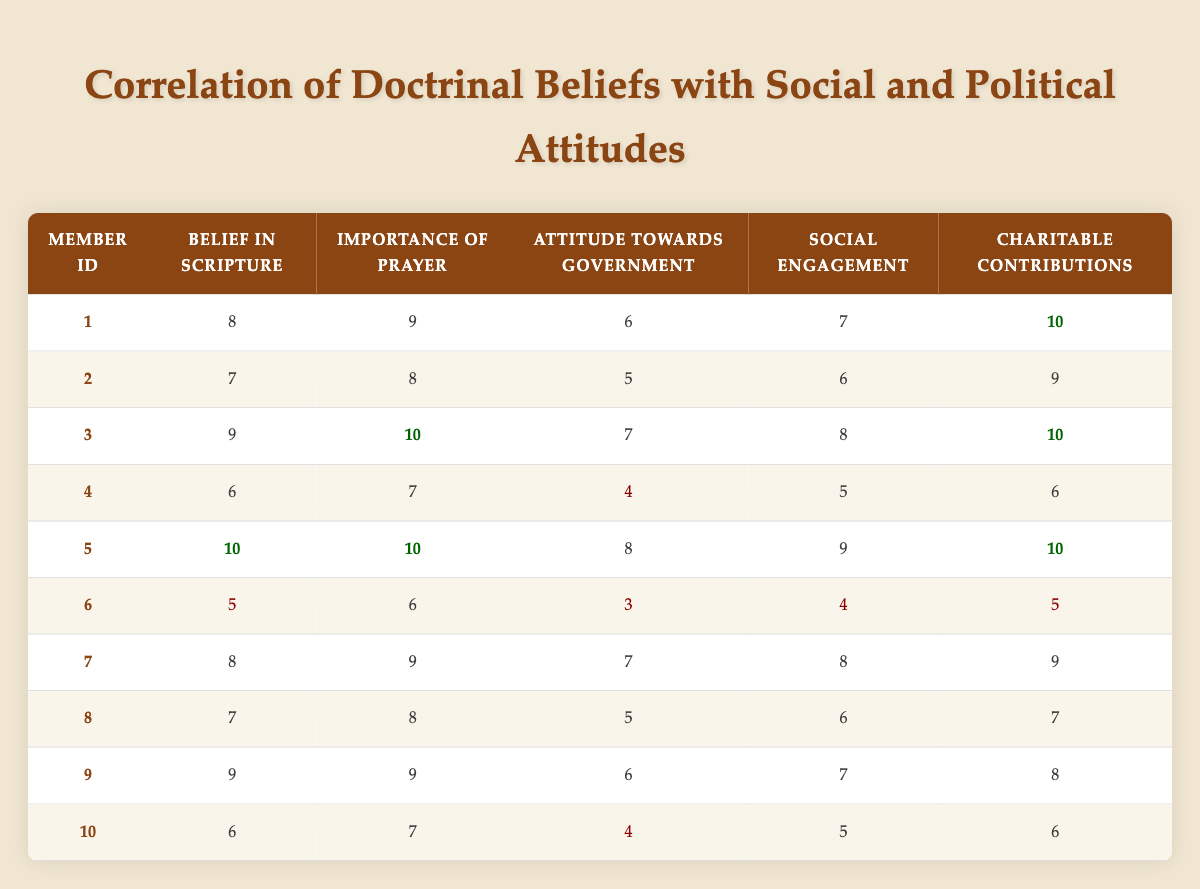What is the belief in Scripture score for member ID 3? By looking at the table, member ID 3 has a belief in Scripture score of 9 listed in the corresponding column.
Answer: 9 What are the charitable contributions of member ID 5? The table shows that member ID 5 has a charitable contributions score of 10, which is noted in the respective column.
Answer: 10 Which member has the lowest attitude towards government? The lowest attitude towards government score in the table is 3, belonging to member ID 6.
Answer: Member ID 6 What is the average social engagement score for all members? The social engagement scores are 7, 6, 8, 5, 9, 4, 8, 6, 7, 5. Summing these scores gives 66, and dividing by 10 (the number of members) provides an average of 6.6.
Answer: 6.6 Is member ID 9's importance of prayer score higher than 8? According to the table, member ID 9 has an importance of prayer score of 9, which is indeed higher than 8.
Answer: Yes How many members scored a perfect 10 in belief in Scripture? From the data, member IDs 5 and 3 both scored a perfect 10 in belief in Scripture, totaling to 2 members with this score.
Answer: 2 What is the difference between the highest and lowest charitable contributions scores? The highest charitable contributions score is 10 (member ID 5) and the lowest is 5 (member ID 6). The difference is calculated as 10 - 5 = 5.
Answer: 5 Which member has the highest importance of prayer score and what is that score? Member ID 3 has the highest importance of prayer score of 10, as shown in the table.
Answer: Member ID 3, score 10 What is the average score for attitude towards government among members with a belief in Scripture of 8 or higher? The scores of members with a belief in Scripture of 8 or higher are: member ID 1 (6), member ID 3 (7), member ID 5 (8), and member ID 7 (7) which add up to 28. There are 4 members with this score, so the average is 28/4 = 7.
Answer: 7 